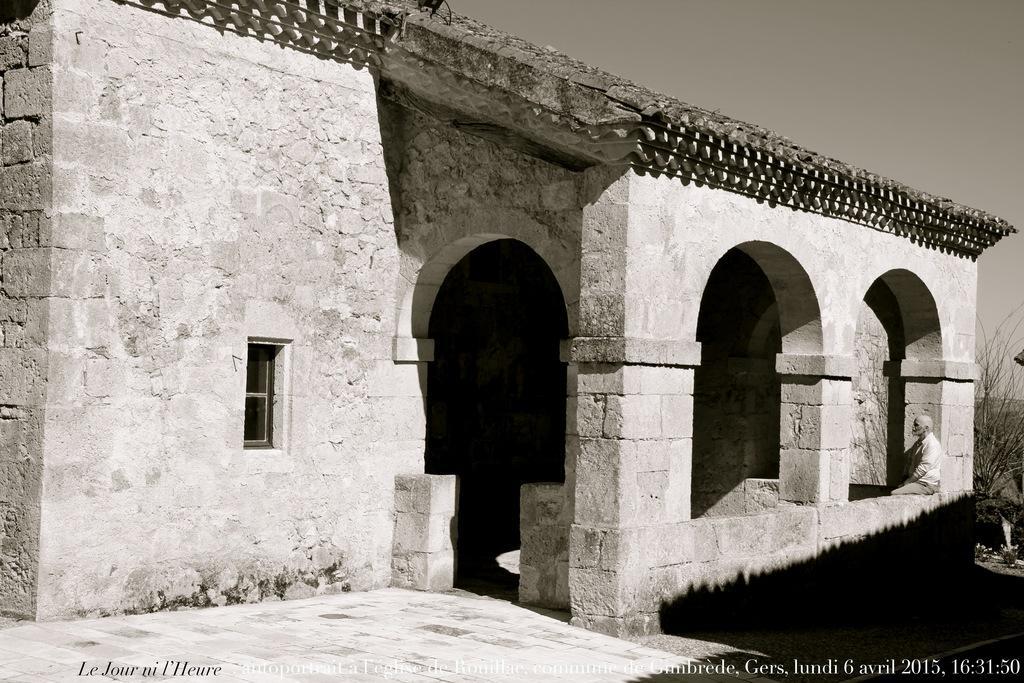Could you give a brief overview of what you see in this image? This image is a black and white image. This image is taken outdoors. At the top of the image there is a sky. At the bottom of the image there is a floor. In the middle of the image there is a house with a few walls, pillars, doors and a window. On the right side of the image there is a plant and a man is sitting on the wall. 